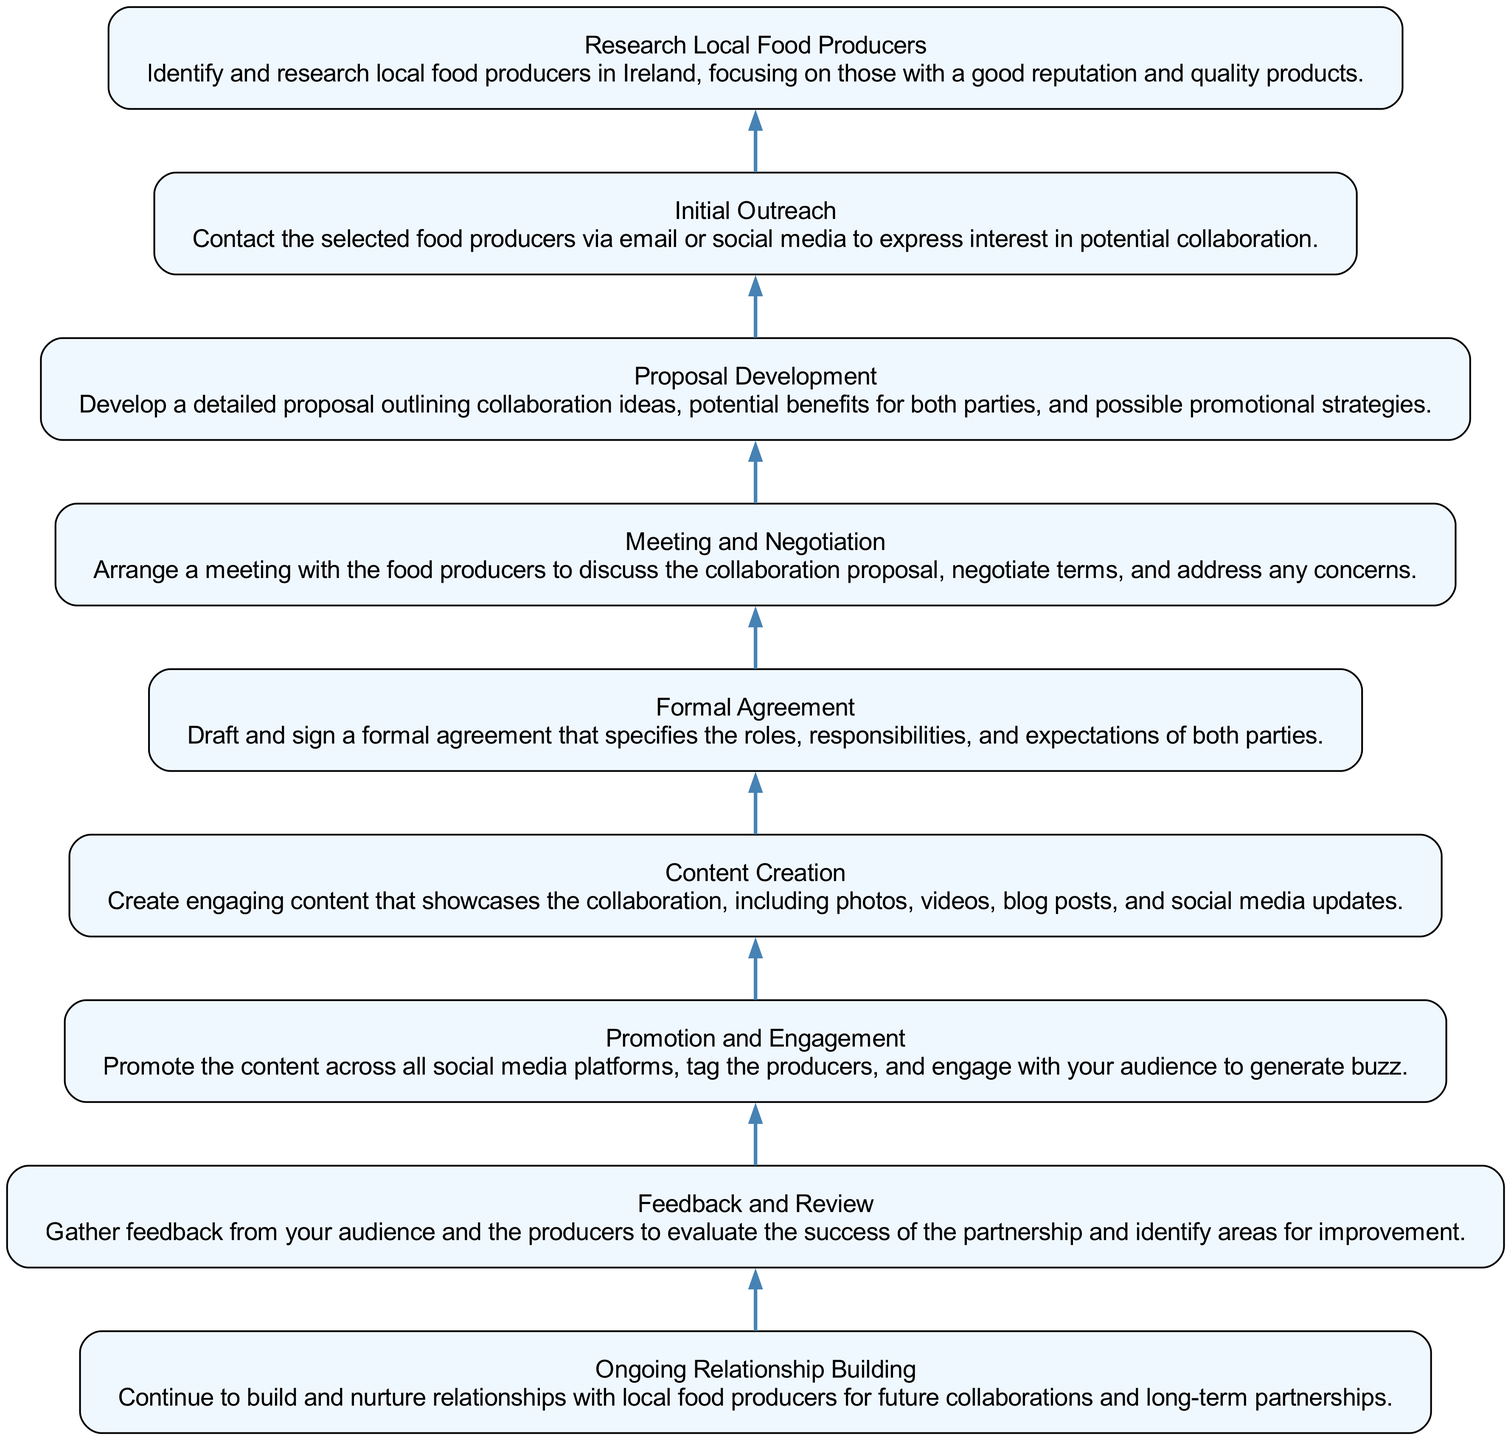What is the first step in the partnership process? The first step in the diagram is "Research Local Food Producers," which is the bottom-most node and indicates the initial action to take.
Answer: Research Local Food Producers How many total steps are illustrated in the diagram? By counting the individual nodes in the diagram, there are nine distinct steps outlined, from research to ongoing relationship building.
Answer: 9 What is the final step in the partnership process? The top-most node of the diagram represents the last step, which is "Ongoing Relationship Building," indicating the conclusion of the outlined process.
Answer: Ongoing Relationship Building Which step directly follows "Formal Agreement"? "Content Creation" directly follows "Formal Agreement" as per the upward flow of the diagram, indicating that content should be created post-agreement.
Answer: Content Creation What type of agreement is mentioned in the process? The diagram specifies a "Formal Agreement," which outlines the roles and responsibilities of both parties, indicating it is a legally binding document.
Answer: Formal Agreement How does "Promotion and Engagement" relate to "Content Creation"? "Promotion and Engagement" follows "Content Creation" in the diagram, suggesting that content should be actively promoted after it has been created to maximize reach and engagement.
Answer: Follows What is the focus of the "Feedback and Review" step? The goal of "Feedback and Review" is to gather input from both the audience and the food producers to assess the success of the partnership, providing insight for future improvements.
Answer: Evaluate success What is developed before the meeting with food producers? The step "Proposal Development" is completed before the meeting, indicating that a detailed plan for collaboration must be prepared prior to discussions.
Answer: Proposal Development What action is to be taken after "Initial Outreach"? The action that follows "Initial Outreach" is "Proposal Development," which means developing a proposal is the next step after reaching out.
Answer: Proposal Development 